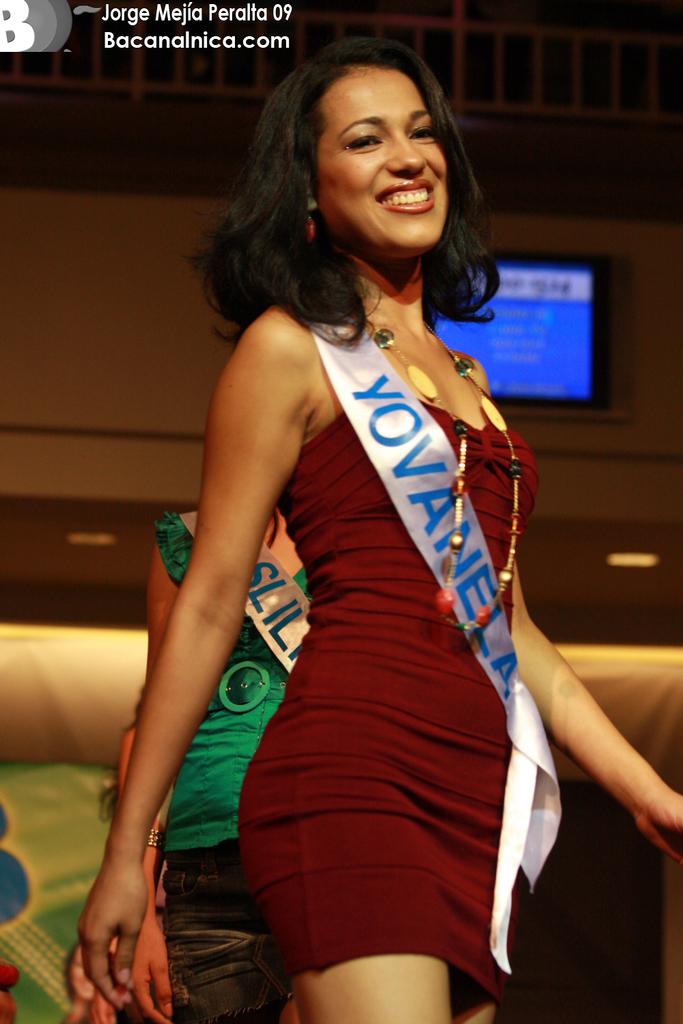Which website took this photo?
Ensure brevity in your answer.  Bacanalnica.com. What does her sash say?
Provide a succinct answer. Yovanela. 